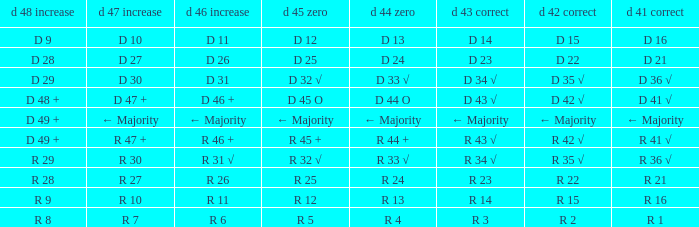What is the value of D 47 + when the value of D 44 O is r 24? R 27. 